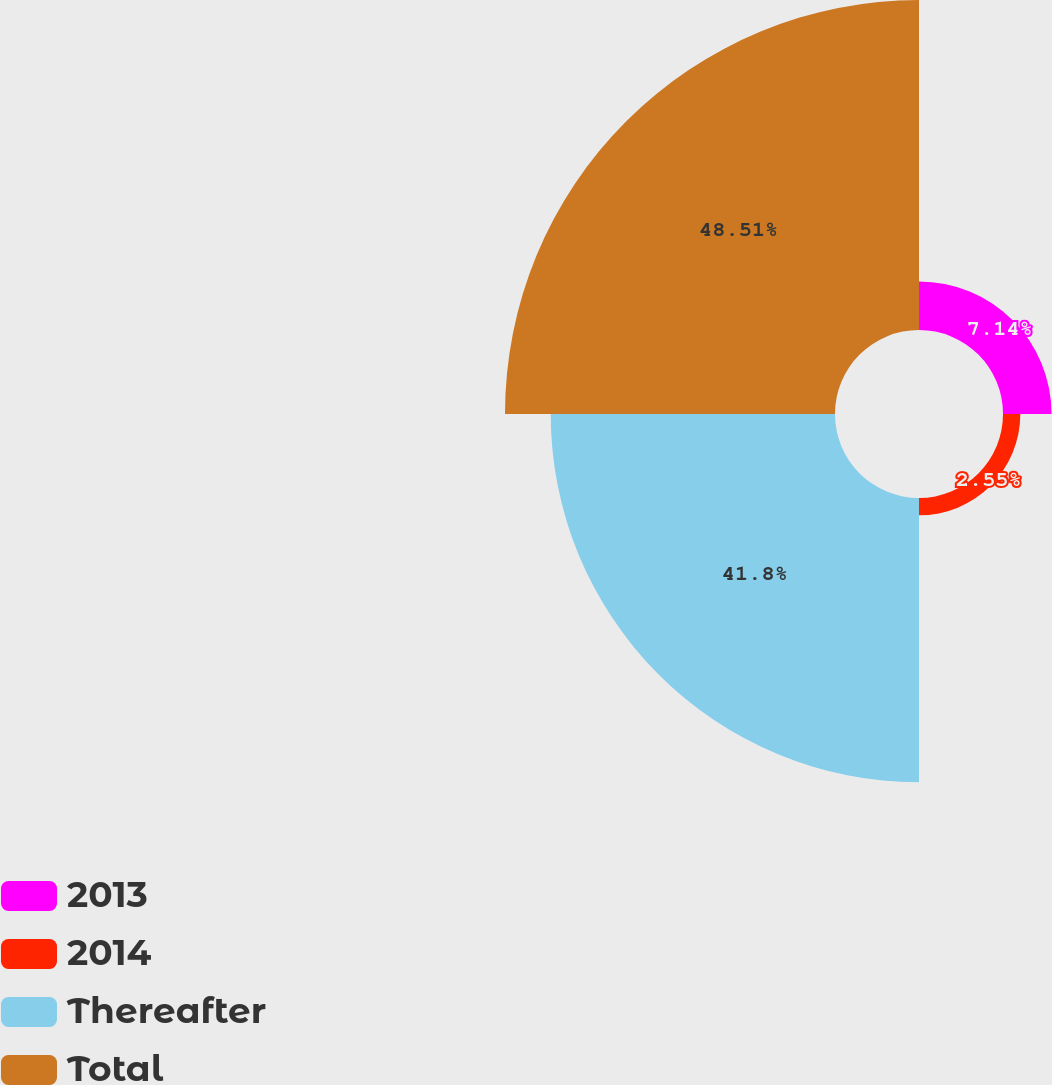Convert chart. <chart><loc_0><loc_0><loc_500><loc_500><pie_chart><fcel>2013<fcel>2014<fcel>Thereafter<fcel>Total<nl><fcel>7.14%<fcel>2.55%<fcel>41.8%<fcel>48.52%<nl></chart> 